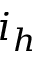<formula> <loc_0><loc_0><loc_500><loc_500>i _ { h }</formula> 